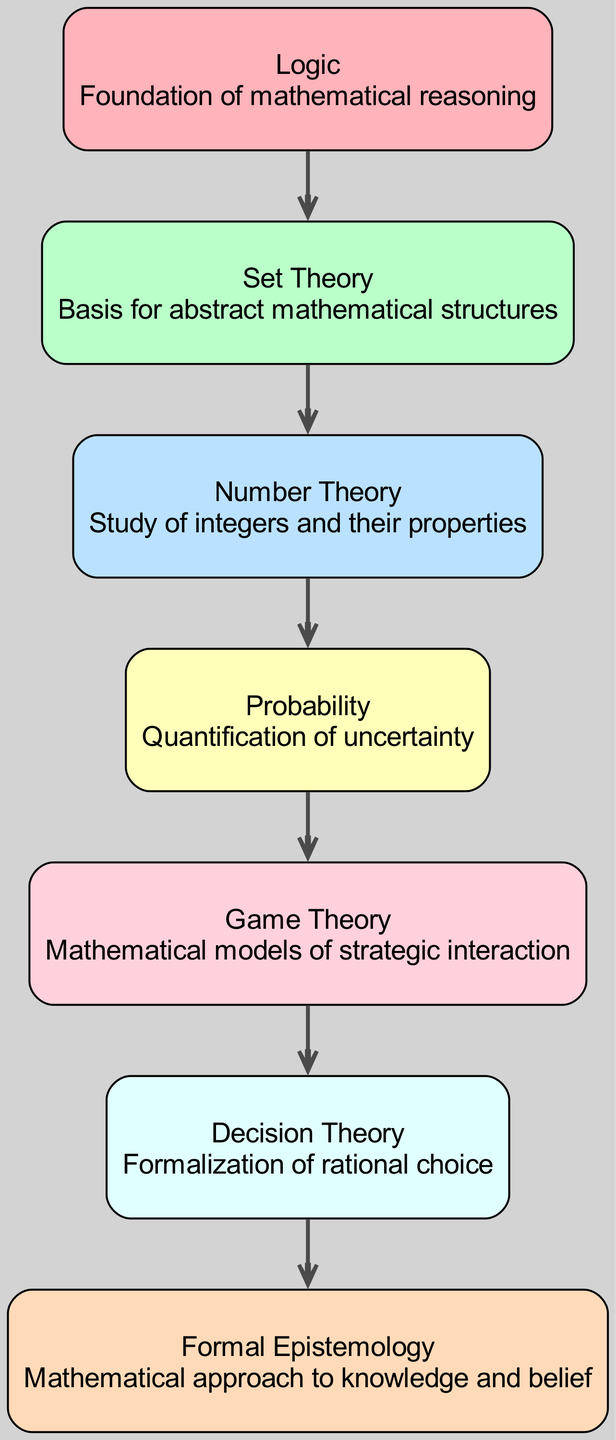What is the top node in the food chain? The top node in the food chain represents the most complex concept, which is Formal Epistemology. By examining the diagram, we can see that it is positioned at the highest level (level 7).
Answer: Formal Epistemology How many levels are in the food chain? The diagram displays 7 distinct levels, each representing a mathematical concept in philosophy, starting from Logic and ending with Formal Epistemology.
Answer: 7 What is the relationship between Set Theory and Number Theory? The relationship is that Set Theory is a prerequisite for Number Theory. In the diagram, Set Theory is positioned before Number Theory (level 2 leads to level 3).
Answer: Prerequisite Which node represents the study of integers? The node that represents the study of integers is Number Theory. Looking at the node descriptions in the diagram, Number Theory is specifically described as "Study of integers and their properties."
Answer: Number Theory What color is the node for Probability? The node for Probability is colored in a light shade, specifically the fourth color from the defined color scheme in the diagram. This color corresponds to '#FFFFBA'.
Answer: Yellow How many edges are there in the food chain? There are 6 edges in the food chain. To find the number of edges, we can count the connections between each node: Logic to Set Theory, Set Theory to Number Theory, Number Theory to Probability, Probability to Game Theory, Game Theory to Decision Theory, and Decision Theory to Formal Epistemology; yielding 6 connections total.
Answer: 6 What is the foundational concept in the food chain? The foundational concept in the food chain is Logic. Based on the diagram's hierarchical structure, Logic is placed at level 1, indicating it is the basis for all other concepts.
Answer: Logic Which concept comes after Game Theory? The concept that comes after Game Theory is Decision Theory. In the diagram, Decision Theory is positioned directly below Game Theory (level 5 leads to level 6).
Answer: Decision Theory 